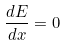Convert formula to latex. <formula><loc_0><loc_0><loc_500><loc_500>\frac { d E } { d x } = 0</formula> 